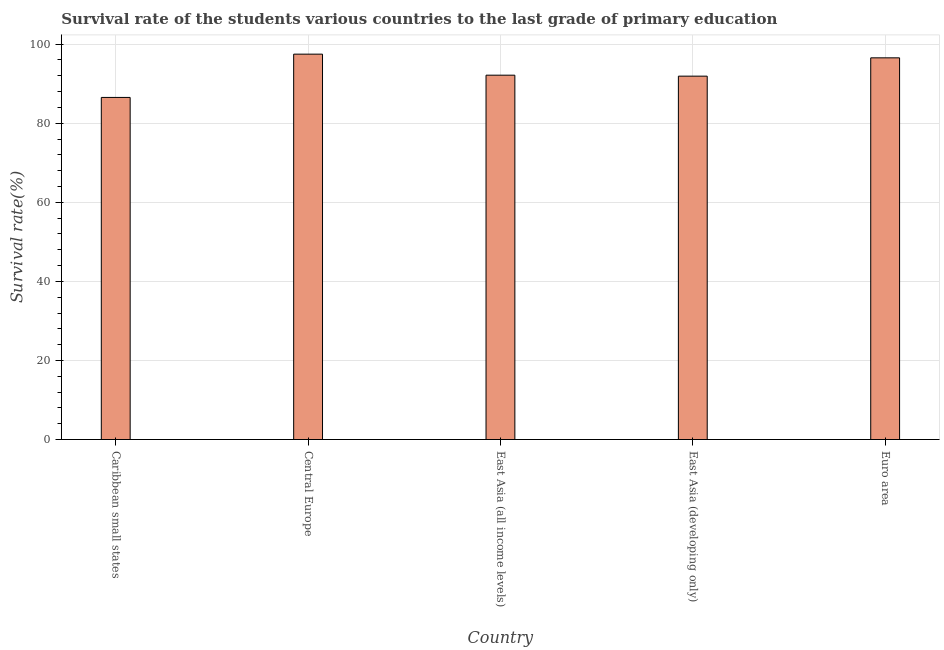What is the title of the graph?
Provide a short and direct response. Survival rate of the students various countries to the last grade of primary education. What is the label or title of the Y-axis?
Your answer should be compact. Survival rate(%). What is the survival rate in primary education in East Asia (developing only)?
Your response must be concise. 91.91. Across all countries, what is the maximum survival rate in primary education?
Offer a terse response. 97.47. Across all countries, what is the minimum survival rate in primary education?
Your answer should be compact. 86.53. In which country was the survival rate in primary education maximum?
Ensure brevity in your answer.  Central Europe. In which country was the survival rate in primary education minimum?
Your response must be concise. Caribbean small states. What is the sum of the survival rate in primary education?
Your response must be concise. 464.59. What is the difference between the survival rate in primary education in Caribbean small states and Euro area?
Provide a succinct answer. -10.01. What is the average survival rate in primary education per country?
Your answer should be compact. 92.92. What is the median survival rate in primary education?
Offer a very short reply. 92.15. What is the ratio of the survival rate in primary education in Caribbean small states to that in East Asia (developing only)?
Offer a very short reply. 0.94. Is the survival rate in primary education in Central Europe less than that in East Asia (all income levels)?
Provide a succinct answer. No. What is the difference between the highest and the second highest survival rate in primary education?
Your answer should be very brief. 0.93. What is the difference between the highest and the lowest survival rate in primary education?
Offer a terse response. 10.95. How many bars are there?
Offer a very short reply. 5. Are all the bars in the graph horizontal?
Offer a terse response. No. How many countries are there in the graph?
Your answer should be compact. 5. What is the Survival rate(%) in Caribbean small states?
Your answer should be very brief. 86.53. What is the Survival rate(%) of Central Europe?
Offer a very short reply. 97.47. What is the Survival rate(%) of East Asia (all income levels)?
Your answer should be very brief. 92.15. What is the Survival rate(%) in East Asia (developing only)?
Provide a short and direct response. 91.91. What is the Survival rate(%) of Euro area?
Your answer should be compact. 96.54. What is the difference between the Survival rate(%) in Caribbean small states and Central Europe?
Provide a short and direct response. -10.95. What is the difference between the Survival rate(%) in Caribbean small states and East Asia (all income levels)?
Your answer should be compact. -5.62. What is the difference between the Survival rate(%) in Caribbean small states and East Asia (developing only)?
Give a very brief answer. -5.38. What is the difference between the Survival rate(%) in Caribbean small states and Euro area?
Make the answer very short. -10.01. What is the difference between the Survival rate(%) in Central Europe and East Asia (all income levels)?
Provide a short and direct response. 5.32. What is the difference between the Survival rate(%) in Central Europe and East Asia (developing only)?
Ensure brevity in your answer.  5.57. What is the difference between the Survival rate(%) in Central Europe and Euro area?
Ensure brevity in your answer.  0.93. What is the difference between the Survival rate(%) in East Asia (all income levels) and East Asia (developing only)?
Offer a very short reply. 0.24. What is the difference between the Survival rate(%) in East Asia (all income levels) and Euro area?
Provide a succinct answer. -4.39. What is the difference between the Survival rate(%) in East Asia (developing only) and Euro area?
Provide a short and direct response. -4.63. What is the ratio of the Survival rate(%) in Caribbean small states to that in Central Europe?
Your answer should be very brief. 0.89. What is the ratio of the Survival rate(%) in Caribbean small states to that in East Asia (all income levels)?
Make the answer very short. 0.94. What is the ratio of the Survival rate(%) in Caribbean small states to that in East Asia (developing only)?
Provide a short and direct response. 0.94. What is the ratio of the Survival rate(%) in Caribbean small states to that in Euro area?
Offer a terse response. 0.9. What is the ratio of the Survival rate(%) in Central Europe to that in East Asia (all income levels)?
Make the answer very short. 1.06. What is the ratio of the Survival rate(%) in Central Europe to that in East Asia (developing only)?
Keep it short and to the point. 1.06. What is the ratio of the Survival rate(%) in Central Europe to that in Euro area?
Your response must be concise. 1.01. What is the ratio of the Survival rate(%) in East Asia (all income levels) to that in Euro area?
Your answer should be very brief. 0.95. 